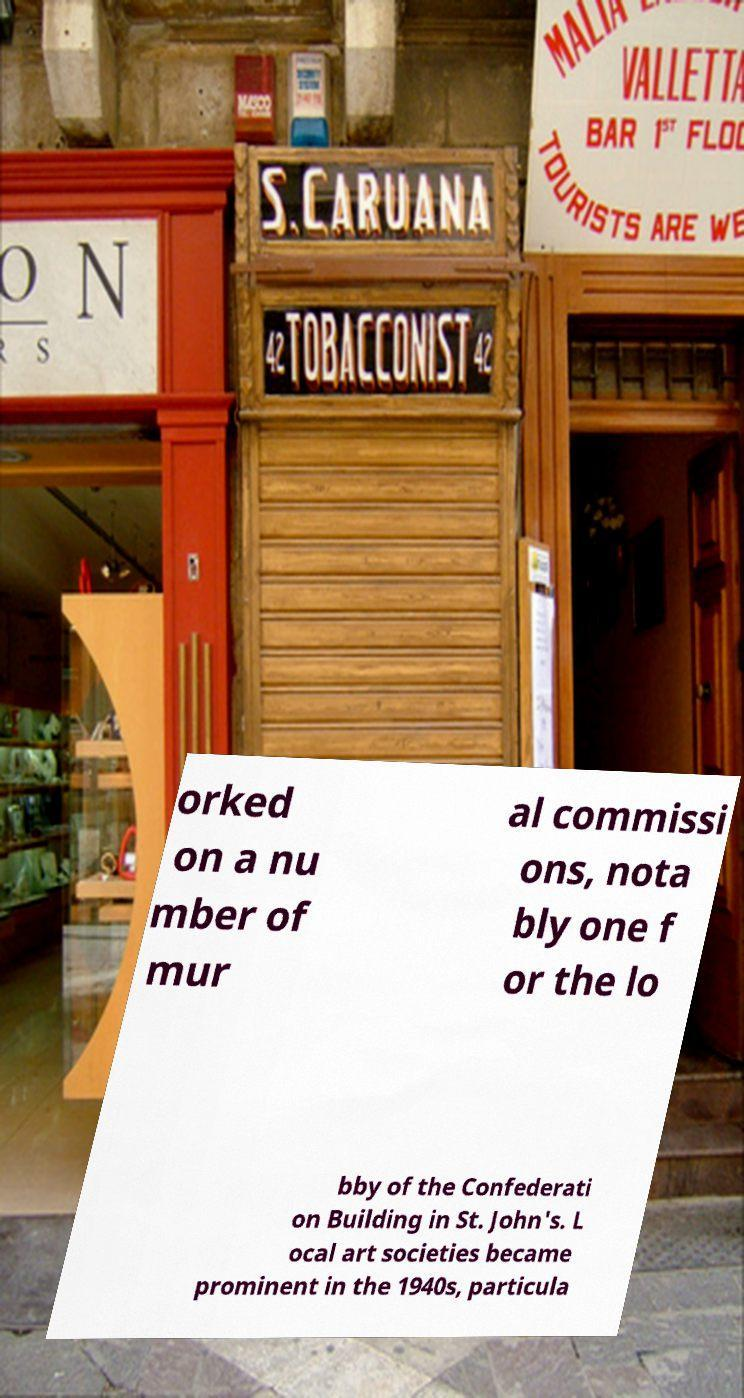Could you assist in decoding the text presented in this image and type it out clearly? orked on a nu mber of mur al commissi ons, nota bly one f or the lo bby of the Confederati on Building in St. John's. L ocal art societies became prominent in the 1940s, particula 